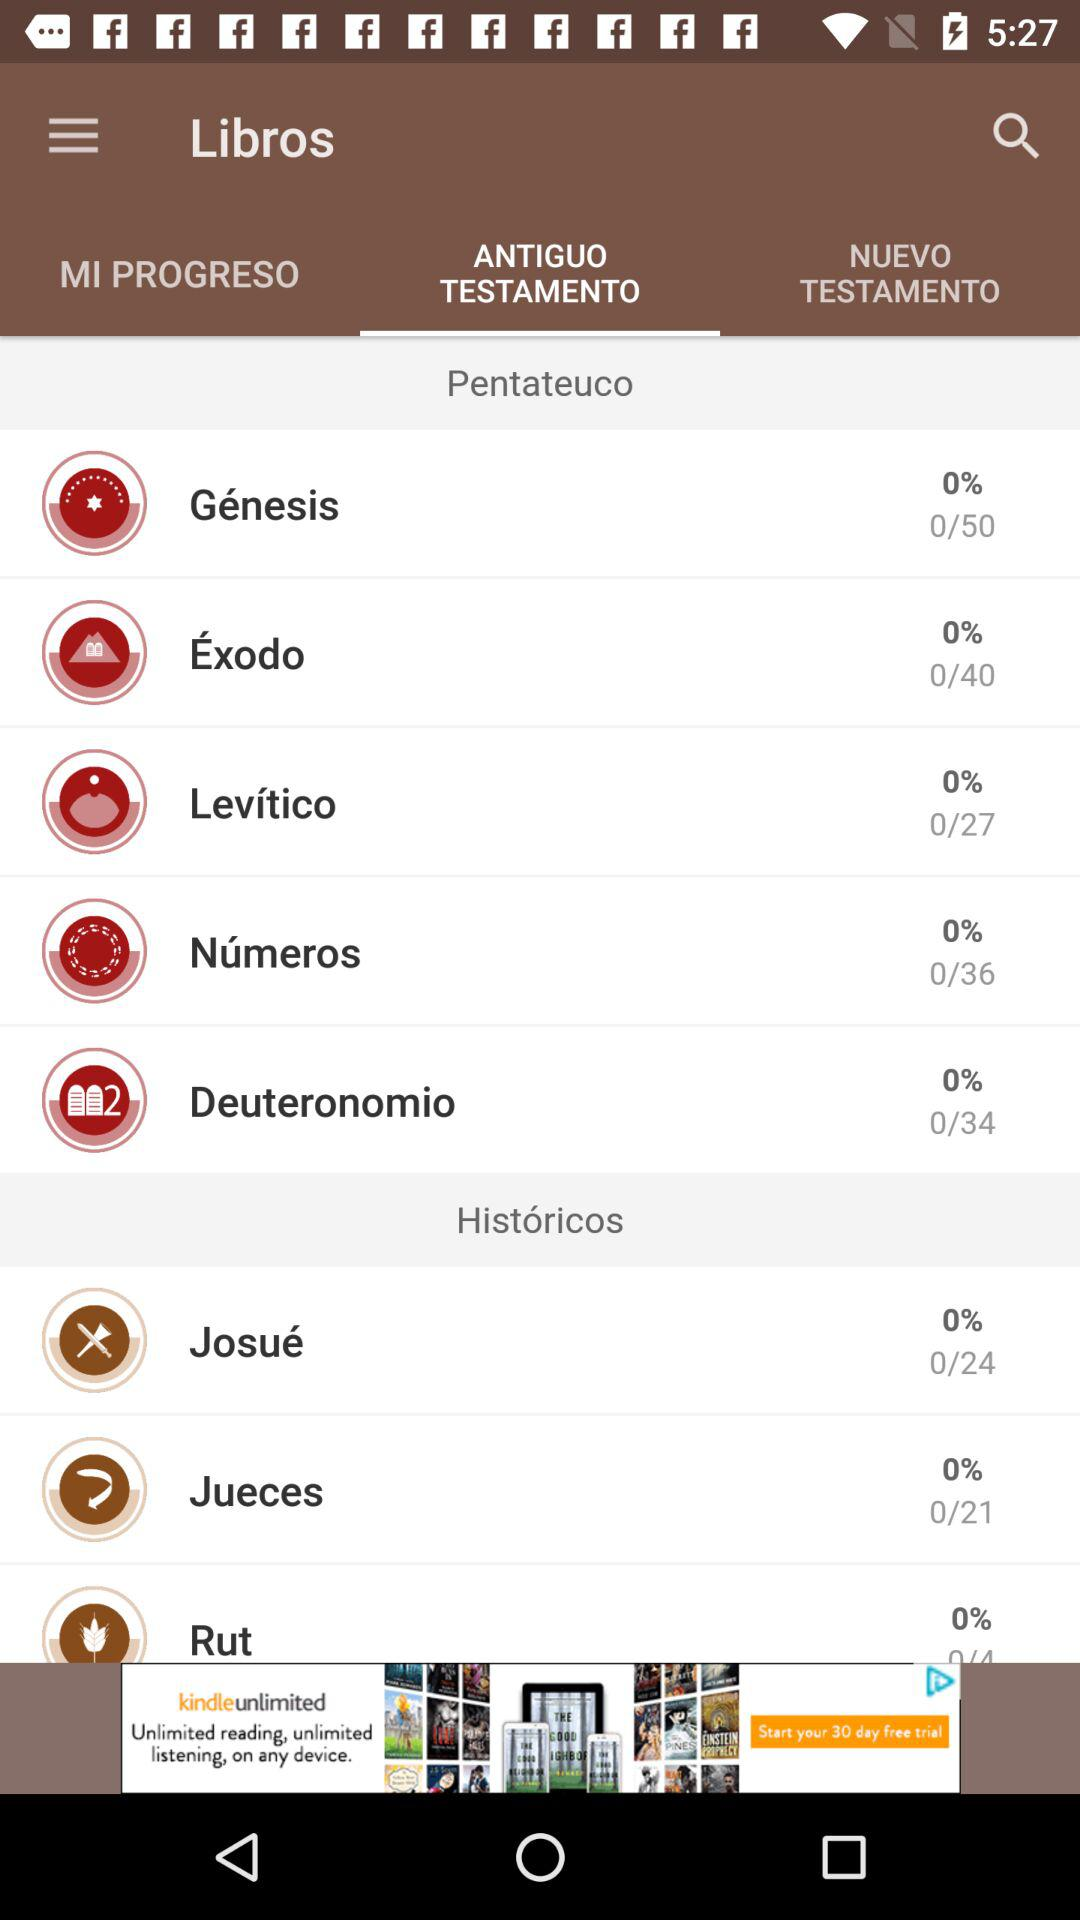How many books are in the Pentateuco?
Answer the question using a single word or phrase. 5 